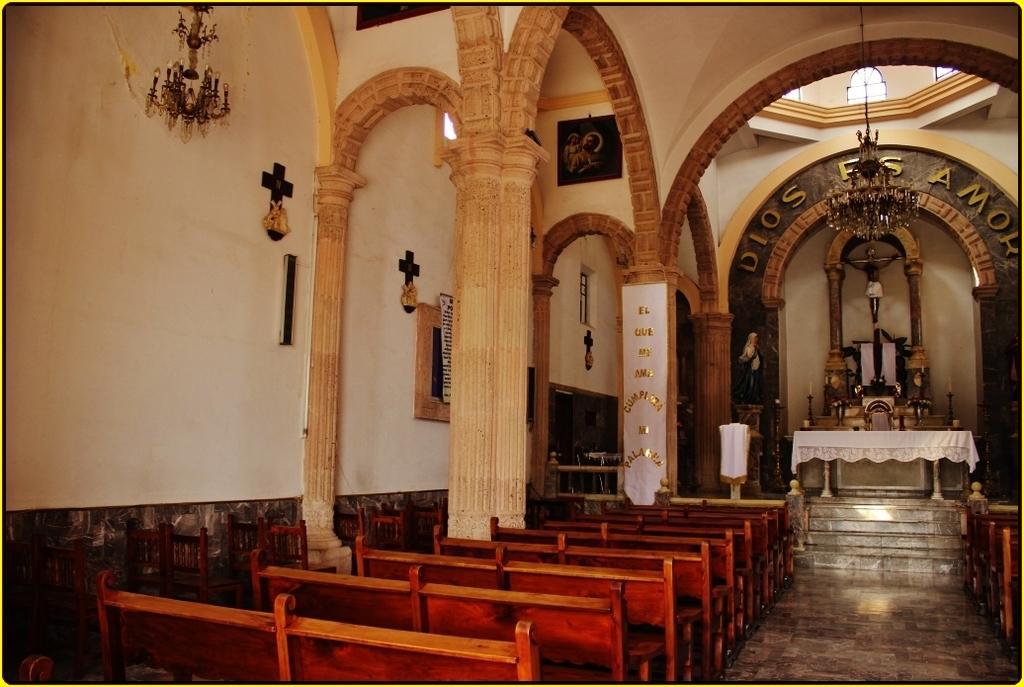Can you describe this image briefly? In this image on the left side I can see the benches. At the top I can see the lights. In the background, I can see some text written on the wall. 